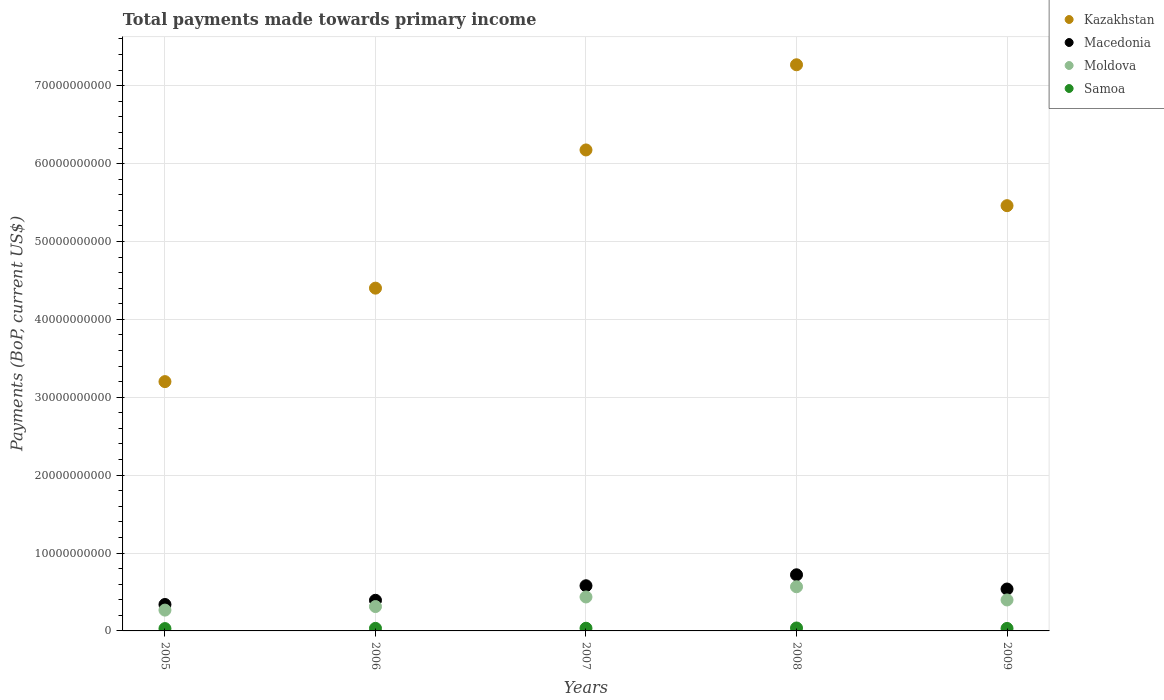Is the number of dotlines equal to the number of legend labels?
Ensure brevity in your answer.  Yes. What is the total payments made towards primary income in Macedonia in 2009?
Your answer should be very brief. 5.38e+09. Across all years, what is the maximum total payments made towards primary income in Samoa?
Give a very brief answer. 3.77e+08. Across all years, what is the minimum total payments made towards primary income in Kazakhstan?
Ensure brevity in your answer.  3.20e+1. What is the total total payments made towards primary income in Kazakhstan in the graph?
Provide a short and direct response. 2.65e+11. What is the difference between the total payments made towards primary income in Samoa in 2007 and that in 2008?
Make the answer very short. -3.25e+07. What is the difference between the total payments made towards primary income in Moldova in 2005 and the total payments made towards primary income in Macedonia in 2007?
Offer a terse response. -3.13e+09. What is the average total payments made towards primary income in Macedonia per year?
Offer a terse response. 5.14e+09. In the year 2008, what is the difference between the total payments made towards primary income in Kazakhstan and total payments made towards primary income in Macedonia?
Your answer should be compact. 6.55e+1. What is the ratio of the total payments made towards primary income in Macedonia in 2005 to that in 2008?
Offer a terse response. 0.47. Is the difference between the total payments made towards primary income in Kazakhstan in 2006 and 2007 greater than the difference between the total payments made towards primary income in Macedonia in 2006 and 2007?
Provide a short and direct response. No. What is the difference between the highest and the second highest total payments made towards primary income in Samoa?
Your response must be concise. 3.25e+07. What is the difference between the highest and the lowest total payments made towards primary income in Macedonia?
Keep it short and to the point. 3.81e+09. Is the sum of the total payments made towards primary income in Samoa in 2006 and 2007 greater than the maximum total payments made towards primary income in Moldova across all years?
Make the answer very short. No. Does the total payments made towards primary income in Kazakhstan monotonically increase over the years?
Ensure brevity in your answer.  No. What is the difference between two consecutive major ticks on the Y-axis?
Offer a terse response. 1.00e+1. Where does the legend appear in the graph?
Offer a very short reply. Top right. How many legend labels are there?
Make the answer very short. 4. How are the legend labels stacked?
Offer a terse response. Vertical. What is the title of the graph?
Your answer should be compact. Total payments made towards primary income. What is the label or title of the X-axis?
Provide a short and direct response. Years. What is the label or title of the Y-axis?
Your response must be concise. Payments (BoP, current US$). What is the Payments (BoP, current US$) in Kazakhstan in 2005?
Your answer should be very brief. 3.20e+1. What is the Payments (BoP, current US$) of Macedonia in 2005?
Ensure brevity in your answer.  3.39e+09. What is the Payments (BoP, current US$) of Moldova in 2005?
Keep it short and to the point. 2.67e+09. What is the Payments (BoP, current US$) in Samoa in 2005?
Provide a succinct answer. 3.00e+08. What is the Payments (BoP, current US$) in Kazakhstan in 2006?
Your answer should be compact. 4.40e+1. What is the Payments (BoP, current US$) in Macedonia in 2006?
Your answer should be compact. 3.93e+09. What is the Payments (BoP, current US$) in Moldova in 2006?
Ensure brevity in your answer.  3.13e+09. What is the Payments (BoP, current US$) in Samoa in 2006?
Your answer should be very brief. 3.29e+08. What is the Payments (BoP, current US$) in Kazakhstan in 2007?
Your answer should be very brief. 6.18e+1. What is the Payments (BoP, current US$) in Macedonia in 2007?
Ensure brevity in your answer.  5.80e+09. What is the Payments (BoP, current US$) in Moldova in 2007?
Provide a succinct answer. 4.36e+09. What is the Payments (BoP, current US$) in Samoa in 2007?
Keep it short and to the point. 3.44e+08. What is the Payments (BoP, current US$) of Kazakhstan in 2008?
Provide a succinct answer. 7.27e+1. What is the Payments (BoP, current US$) in Macedonia in 2008?
Keep it short and to the point. 7.21e+09. What is the Payments (BoP, current US$) in Moldova in 2008?
Offer a very short reply. 5.67e+09. What is the Payments (BoP, current US$) in Samoa in 2008?
Keep it short and to the point. 3.77e+08. What is the Payments (BoP, current US$) of Kazakhstan in 2009?
Make the answer very short. 5.46e+1. What is the Payments (BoP, current US$) in Macedonia in 2009?
Your answer should be very brief. 5.38e+09. What is the Payments (BoP, current US$) of Moldova in 2009?
Your answer should be very brief. 3.97e+09. What is the Payments (BoP, current US$) of Samoa in 2009?
Your response must be concise. 3.20e+08. Across all years, what is the maximum Payments (BoP, current US$) of Kazakhstan?
Keep it short and to the point. 7.27e+1. Across all years, what is the maximum Payments (BoP, current US$) in Macedonia?
Keep it short and to the point. 7.21e+09. Across all years, what is the maximum Payments (BoP, current US$) in Moldova?
Offer a very short reply. 5.67e+09. Across all years, what is the maximum Payments (BoP, current US$) in Samoa?
Make the answer very short. 3.77e+08. Across all years, what is the minimum Payments (BoP, current US$) of Kazakhstan?
Your answer should be very brief. 3.20e+1. Across all years, what is the minimum Payments (BoP, current US$) of Macedonia?
Keep it short and to the point. 3.39e+09. Across all years, what is the minimum Payments (BoP, current US$) of Moldova?
Make the answer very short. 2.67e+09. Across all years, what is the minimum Payments (BoP, current US$) in Samoa?
Your response must be concise. 3.00e+08. What is the total Payments (BoP, current US$) of Kazakhstan in the graph?
Provide a succinct answer. 2.65e+11. What is the total Payments (BoP, current US$) in Macedonia in the graph?
Give a very brief answer. 2.57e+1. What is the total Payments (BoP, current US$) of Moldova in the graph?
Provide a succinct answer. 1.98e+1. What is the total Payments (BoP, current US$) in Samoa in the graph?
Your response must be concise. 1.67e+09. What is the difference between the Payments (BoP, current US$) in Kazakhstan in 2005 and that in 2006?
Keep it short and to the point. -1.20e+1. What is the difference between the Payments (BoP, current US$) in Macedonia in 2005 and that in 2006?
Provide a short and direct response. -5.40e+08. What is the difference between the Payments (BoP, current US$) in Moldova in 2005 and that in 2006?
Ensure brevity in your answer.  -4.56e+08. What is the difference between the Payments (BoP, current US$) of Samoa in 2005 and that in 2006?
Your response must be concise. -2.86e+07. What is the difference between the Payments (BoP, current US$) of Kazakhstan in 2005 and that in 2007?
Your answer should be very brief. -2.97e+1. What is the difference between the Payments (BoP, current US$) of Macedonia in 2005 and that in 2007?
Provide a short and direct response. -2.41e+09. What is the difference between the Payments (BoP, current US$) of Moldova in 2005 and that in 2007?
Keep it short and to the point. -1.69e+09. What is the difference between the Payments (BoP, current US$) of Samoa in 2005 and that in 2007?
Your answer should be very brief. -4.42e+07. What is the difference between the Payments (BoP, current US$) in Kazakhstan in 2005 and that in 2008?
Make the answer very short. -4.07e+1. What is the difference between the Payments (BoP, current US$) in Macedonia in 2005 and that in 2008?
Offer a terse response. -3.81e+09. What is the difference between the Payments (BoP, current US$) in Moldova in 2005 and that in 2008?
Your answer should be compact. -3.00e+09. What is the difference between the Payments (BoP, current US$) in Samoa in 2005 and that in 2008?
Offer a very short reply. -7.67e+07. What is the difference between the Payments (BoP, current US$) of Kazakhstan in 2005 and that in 2009?
Your answer should be compact. -2.26e+1. What is the difference between the Payments (BoP, current US$) in Macedonia in 2005 and that in 2009?
Keep it short and to the point. -1.99e+09. What is the difference between the Payments (BoP, current US$) of Moldova in 2005 and that in 2009?
Provide a succinct answer. -1.30e+09. What is the difference between the Payments (BoP, current US$) of Samoa in 2005 and that in 2009?
Offer a terse response. -1.96e+07. What is the difference between the Payments (BoP, current US$) of Kazakhstan in 2006 and that in 2007?
Make the answer very short. -1.77e+1. What is the difference between the Payments (BoP, current US$) in Macedonia in 2006 and that in 2007?
Your answer should be very brief. -1.87e+09. What is the difference between the Payments (BoP, current US$) in Moldova in 2006 and that in 2007?
Make the answer very short. -1.23e+09. What is the difference between the Payments (BoP, current US$) of Samoa in 2006 and that in 2007?
Your answer should be very brief. -1.56e+07. What is the difference between the Payments (BoP, current US$) in Kazakhstan in 2006 and that in 2008?
Provide a succinct answer. -2.87e+1. What is the difference between the Payments (BoP, current US$) in Macedonia in 2006 and that in 2008?
Your answer should be very brief. -3.27e+09. What is the difference between the Payments (BoP, current US$) of Moldova in 2006 and that in 2008?
Offer a terse response. -2.54e+09. What is the difference between the Payments (BoP, current US$) of Samoa in 2006 and that in 2008?
Offer a very short reply. -4.81e+07. What is the difference between the Payments (BoP, current US$) of Kazakhstan in 2006 and that in 2009?
Make the answer very short. -1.06e+1. What is the difference between the Payments (BoP, current US$) of Macedonia in 2006 and that in 2009?
Offer a terse response. -1.45e+09. What is the difference between the Payments (BoP, current US$) in Moldova in 2006 and that in 2009?
Offer a terse response. -8.46e+08. What is the difference between the Payments (BoP, current US$) in Samoa in 2006 and that in 2009?
Ensure brevity in your answer.  8.97e+06. What is the difference between the Payments (BoP, current US$) of Kazakhstan in 2007 and that in 2008?
Provide a succinct answer. -1.09e+1. What is the difference between the Payments (BoP, current US$) in Macedonia in 2007 and that in 2008?
Ensure brevity in your answer.  -1.41e+09. What is the difference between the Payments (BoP, current US$) in Moldova in 2007 and that in 2008?
Your response must be concise. -1.31e+09. What is the difference between the Payments (BoP, current US$) in Samoa in 2007 and that in 2008?
Your answer should be compact. -3.25e+07. What is the difference between the Payments (BoP, current US$) of Kazakhstan in 2007 and that in 2009?
Ensure brevity in your answer.  7.15e+09. What is the difference between the Payments (BoP, current US$) in Macedonia in 2007 and that in 2009?
Keep it short and to the point. 4.20e+08. What is the difference between the Payments (BoP, current US$) in Moldova in 2007 and that in 2009?
Keep it short and to the point. 3.84e+08. What is the difference between the Payments (BoP, current US$) in Samoa in 2007 and that in 2009?
Provide a short and direct response. 2.46e+07. What is the difference between the Payments (BoP, current US$) of Kazakhstan in 2008 and that in 2009?
Provide a short and direct response. 1.81e+1. What is the difference between the Payments (BoP, current US$) in Macedonia in 2008 and that in 2009?
Make the answer very short. 1.83e+09. What is the difference between the Payments (BoP, current US$) in Moldova in 2008 and that in 2009?
Offer a terse response. 1.70e+09. What is the difference between the Payments (BoP, current US$) in Samoa in 2008 and that in 2009?
Your answer should be compact. 5.70e+07. What is the difference between the Payments (BoP, current US$) in Kazakhstan in 2005 and the Payments (BoP, current US$) in Macedonia in 2006?
Offer a terse response. 2.81e+1. What is the difference between the Payments (BoP, current US$) in Kazakhstan in 2005 and the Payments (BoP, current US$) in Moldova in 2006?
Provide a short and direct response. 2.89e+1. What is the difference between the Payments (BoP, current US$) in Kazakhstan in 2005 and the Payments (BoP, current US$) in Samoa in 2006?
Provide a succinct answer. 3.17e+1. What is the difference between the Payments (BoP, current US$) of Macedonia in 2005 and the Payments (BoP, current US$) of Moldova in 2006?
Keep it short and to the point. 2.64e+08. What is the difference between the Payments (BoP, current US$) in Macedonia in 2005 and the Payments (BoP, current US$) in Samoa in 2006?
Ensure brevity in your answer.  3.06e+09. What is the difference between the Payments (BoP, current US$) in Moldova in 2005 and the Payments (BoP, current US$) in Samoa in 2006?
Your answer should be compact. 2.34e+09. What is the difference between the Payments (BoP, current US$) in Kazakhstan in 2005 and the Payments (BoP, current US$) in Macedonia in 2007?
Offer a terse response. 2.62e+1. What is the difference between the Payments (BoP, current US$) of Kazakhstan in 2005 and the Payments (BoP, current US$) of Moldova in 2007?
Give a very brief answer. 2.76e+1. What is the difference between the Payments (BoP, current US$) of Kazakhstan in 2005 and the Payments (BoP, current US$) of Samoa in 2007?
Provide a succinct answer. 3.17e+1. What is the difference between the Payments (BoP, current US$) in Macedonia in 2005 and the Payments (BoP, current US$) in Moldova in 2007?
Keep it short and to the point. -9.66e+08. What is the difference between the Payments (BoP, current US$) of Macedonia in 2005 and the Payments (BoP, current US$) of Samoa in 2007?
Provide a succinct answer. 3.05e+09. What is the difference between the Payments (BoP, current US$) of Moldova in 2005 and the Payments (BoP, current US$) of Samoa in 2007?
Offer a very short reply. 2.33e+09. What is the difference between the Payments (BoP, current US$) of Kazakhstan in 2005 and the Payments (BoP, current US$) of Macedonia in 2008?
Provide a succinct answer. 2.48e+1. What is the difference between the Payments (BoP, current US$) of Kazakhstan in 2005 and the Payments (BoP, current US$) of Moldova in 2008?
Make the answer very short. 2.63e+1. What is the difference between the Payments (BoP, current US$) of Kazakhstan in 2005 and the Payments (BoP, current US$) of Samoa in 2008?
Give a very brief answer. 3.16e+1. What is the difference between the Payments (BoP, current US$) in Macedonia in 2005 and the Payments (BoP, current US$) in Moldova in 2008?
Your response must be concise. -2.28e+09. What is the difference between the Payments (BoP, current US$) in Macedonia in 2005 and the Payments (BoP, current US$) in Samoa in 2008?
Provide a short and direct response. 3.02e+09. What is the difference between the Payments (BoP, current US$) in Moldova in 2005 and the Payments (BoP, current US$) in Samoa in 2008?
Provide a succinct answer. 2.30e+09. What is the difference between the Payments (BoP, current US$) of Kazakhstan in 2005 and the Payments (BoP, current US$) of Macedonia in 2009?
Offer a terse response. 2.66e+1. What is the difference between the Payments (BoP, current US$) in Kazakhstan in 2005 and the Payments (BoP, current US$) in Moldova in 2009?
Provide a short and direct response. 2.80e+1. What is the difference between the Payments (BoP, current US$) of Kazakhstan in 2005 and the Payments (BoP, current US$) of Samoa in 2009?
Provide a succinct answer. 3.17e+1. What is the difference between the Payments (BoP, current US$) of Macedonia in 2005 and the Payments (BoP, current US$) of Moldova in 2009?
Offer a very short reply. -5.82e+08. What is the difference between the Payments (BoP, current US$) in Macedonia in 2005 and the Payments (BoP, current US$) in Samoa in 2009?
Ensure brevity in your answer.  3.07e+09. What is the difference between the Payments (BoP, current US$) in Moldova in 2005 and the Payments (BoP, current US$) in Samoa in 2009?
Make the answer very short. 2.35e+09. What is the difference between the Payments (BoP, current US$) in Kazakhstan in 2006 and the Payments (BoP, current US$) in Macedonia in 2007?
Your answer should be very brief. 3.82e+1. What is the difference between the Payments (BoP, current US$) of Kazakhstan in 2006 and the Payments (BoP, current US$) of Moldova in 2007?
Offer a terse response. 3.96e+1. What is the difference between the Payments (BoP, current US$) of Kazakhstan in 2006 and the Payments (BoP, current US$) of Samoa in 2007?
Your response must be concise. 4.37e+1. What is the difference between the Payments (BoP, current US$) of Macedonia in 2006 and the Payments (BoP, current US$) of Moldova in 2007?
Provide a short and direct response. -4.26e+08. What is the difference between the Payments (BoP, current US$) in Macedonia in 2006 and the Payments (BoP, current US$) in Samoa in 2007?
Your answer should be compact. 3.59e+09. What is the difference between the Payments (BoP, current US$) of Moldova in 2006 and the Payments (BoP, current US$) of Samoa in 2007?
Provide a succinct answer. 2.78e+09. What is the difference between the Payments (BoP, current US$) of Kazakhstan in 2006 and the Payments (BoP, current US$) of Macedonia in 2008?
Your response must be concise. 3.68e+1. What is the difference between the Payments (BoP, current US$) in Kazakhstan in 2006 and the Payments (BoP, current US$) in Moldova in 2008?
Make the answer very short. 3.83e+1. What is the difference between the Payments (BoP, current US$) in Kazakhstan in 2006 and the Payments (BoP, current US$) in Samoa in 2008?
Ensure brevity in your answer.  4.36e+1. What is the difference between the Payments (BoP, current US$) of Macedonia in 2006 and the Payments (BoP, current US$) of Moldova in 2008?
Your answer should be compact. -1.74e+09. What is the difference between the Payments (BoP, current US$) in Macedonia in 2006 and the Payments (BoP, current US$) in Samoa in 2008?
Your answer should be very brief. 3.56e+09. What is the difference between the Payments (BoP, current US$) in Moldova in 2006 and the Payments (BoP, current US$) in Samoa in 2008?
Your answer should be compact. 2.75e+09. What is the difference between the Payments (BoP, current US$) of Kazakhstan in 2006 and the Payments (BoP, current US$) of Macedonia in 2009?
Your answer should be very brief. 3.86e+1. What is the difference between the Payments (BoP, current US$) of Kazakhstan in 2006 and the Payments (BoP, current US$) of Moldova in 2009?
Ensure brevity in your answer.  4.00e+1. What is the difference between the Payments (BoP, current US$) of Kazakhstan in 2006 and the Payments (BoP, current US$) of Samoa in 2009?
Make the answer very short. 4.37e+1. What is the difference between the Payments (BoP, current US$) in Macedonia in 2006 and the Payments (BoP, current US$) in Moldova in 2009?
Offer a very short reply. -4.25e+07. What is the difference between the Payments (BoP, current US$) of Macedonia in 2006 and the Payments (BoP, current US$) of Samoa in 2009?
Give a very brief answer. 3.61e+09. What is the difference between the Payments (BoP, current US$) of Moldova in 2006 and the Payments (BoP, current US$) of Samoa in 2009?
Keep it short and to the point. 2.81e+09. What is the difference between the Payments (BoP, current US$) of Kazakhstan in 2007 and the Payments (BoP, current US$) of Macedonia in 2008?
Offer a terse response. 5.45e+1. What is the difference between the Payments (BoP, current US$) in Kazakhstan in 2007 and the Payments (BoP, current US$) in Moldova in 2008?
Offer a very short reply. 5.61e+1. What is the difference between the Payments (BoP, current US$) in Kazakhstan in 2007 and the Payments (BoP, current US$) in Samoa in 2008?
Provide a succinct answer. 6.14e+1. What is the difference between the Payments (BoP, current US$) of Macedonia in 2007 and the Payments (BoP, current US$) of Moldova in 2008?
Provide a short and direct response. 1.28e+08. What is the difference between the Payments (BoP, current US$) in Macedonia in 2007 and the Payments (BoP, current US$) in Samoa in 2008?
Offer a terse response. 5.42e+09. What is the difference between the Payments (BoP, current US$) in Moldova in 2007 and the Payments (BoP, current US$) in Samoa in 2008?
Your response must be concise. 3.98e+09. What is the difference between the Payments (BoP, current US$) of Kazakhstan in 2007 and the Payments (BoP, current US$) of Macedonia in 2009?
Provide a short and direct response. 5.64e+1. What is the difference between the Payments (BoP, current US$) in Kazakhstan in 2007 and the Payments (BoP, current US$) in Moldova in 2009?
Give a very brief answer. 5.78e+1. What is the difference between the Payments (BoP, current US$) in Kazakhstan in 2007 and the Payments (BoP, current US$) in Samoa in 2009?
Ensure brevity in your answer.  6.14e+1. What is the difference between the Payments (BoP, current US$) of Macedonia in 2007 and the Payments (BoP, current US$) of Moldova in 2009?
Keep it short and to the point. 1.82e+09. What is the difference between the Payments (BoP, current US$) in Macedonia in 2007 and the Payments (BoP, current US$) in Samoa in 2009?
Offer a very short reply. 5.48e+09. What is the difference between the Payments (BoP, current US$) in Moldova in 2007 and the Payments (BoP, current US$) in Samoa in 2009?
Offer a terse response. 4.04e+09. What is the difference between the Payments (BoP, current US$) of Kazakhstan in 2008 and the Payments (BoP, current US$) of Macedonia in 2009?
Provide a succinct answer. 6.73e+1. What is the difference between the Payments (BoP, current US$) of Kazakhstan in 2008 and the Payments (BoP, current US$) of Moldova in 2009?
Offer a terse response. 6.87e+1. What is the difference between the Payments (BoP, current US$) of Kazakhstan in 2008 and the Payments (BoP, current US$) of Samoa in 2009?
Your answer should be compact. 7.24e+1. What is the difference between the Payments (BoP, current US$) in Macedonia in 2008 and the Payments (BoP, current US$) in Moldova in 2009?
Your answer should be very brief. 3.23e+09. What is the difference between the Payments (BoP, current US$) in Macedonia in 2008 and the Payments (BoP, current US$) in Samoa in 2009?
Make the answer very short. 6.89e+09. What is the difference between the Payments (BoP, current US$) in Moldova in 2008 and the Payments (BoP, current US$) in Samoa in 2009?
Provide a succinct answer. 5.35e+09. What is the average Payments (BoP, current US$) of Kazakhstan per year?
Give a very brief answer. 5.30e+1. What is the average Payments (BoP, current US$) in Macedonia per year?
Your answer should be compact. 5.14e+09. What is the average Payments (BoP, current US$) in Moldova per year?
Keep it short and to the point. 3.96e+09. What is the average Payments (BoP, current US$) of Samoa per year?
Keep it short and to the point. 3.34e+08. In the year 2005, what is the difference between the Payments (BoP, current US$) in Kazakhstan and Payments (BoP, current US$) in Macedonia?
Provide a short and direct response. 2.86e+1. In the year 2005, what is the difference between the Payments (BoP, current US$) in Kazakhstan and Payments (BoP, current US$) in Moldova?
Ensure brevity in your answer.  2.93e+1. In the year 2005, what is the difference between the Payments (BoP, current US$) in Kazakhstan and Payments (BoP, current US$) in Samoa?
Give a very brief answer. 3.17e+1. In the year 2005, what is the difference between the Payments (BoP, current US$) in Macedonia and Payments (BoP, current US$) in Moldova?
Your answer should be compact. 7.20e+08. In the year 2005, what is the difference between the Payments (BoP, current US$) in Macedonia and Payments (BoP, current US$) in Samoa?
Provide a succinct answer. 3.09e+09. In the year 2005, what is the difference between the Payments (BoP, current US$) of Moldova and Payments (BoP, current US$) of Samoa?
Your answer should be compact. 2.37e+09. In the year 2006, what is the difference between the Payments (BoP, current US$) of Kazakhstan and Payments (BoP, current US$) of Macedonia?
Your response must be concise. 4.01e+1. In the year 2006, what is the difference between the Payments (BoP, current US$) in Kazakhstan and Payments (BoP, current US$) in Moldova?
Offer a terse response. 4.09e+1. In the year 2006, what is the difference between the Payments (BoP, current US$) of Kazakhstan and Payments (BoP, current US$) of Samoa?
Keep it short and to the point. 4.37e+1. In the year 2006, what is the difference between the Payments (BoP, current US$) in Macedonia and Payments (BoP, current US$) in Moldova?
Give a very brief answer. 8.04e+08. In the year 2006, what is the difference between the Payments (BoP, current US$) in Macedonia and Payments (BoP, current US$) in Samoa?
Ensure brevity in your answer.  3.60e+09. In the year 2006, what is the difference between the Payments (BoP, current US$) in Moldova and Payments (BoP, current US$) in Samoa?
Give a very brief answer. 2.80e+09. In the year 2007, what is the difference between the Payments (BoP, current US$) in Kazakhstan and Payments (BoP, current US$) in Macedonia?
Provide a short and direct response. 5.60e+1. In the year 2007, what is the difference between the Payments (BoP, current US$) in Kazakhstan and Payments (BoP, current US$) in Moldova?
Make the answer very short. 5.74e+1. In the year 2007, what is the difference between the Payments (BoP, current US$) in Kazakhstan and Payments (BoP, current US$) in Samoa?
Offer a very short reply. 6.14e+1. In the year 2007, what is the difference between the Payments (BoP, current US$) of Macedonia and Payments (BoP, current US$) of Moldova?
Offer a terse response. 1.44e+09. In the year 2007, what is the difference between the Payments (BoP, current US$) of Macedonia and Payments (BoP, current US$) of Samoa?
Provide a succinct answer. 5.45e+09. In the year 2007, what is the difference between the Payments (BoP, current US$) in Moldova and Payments (BoP, current US$) in Samoa?
Give a very brief answer. 4.01e+09. In the year 2008, what is the difference between the Payments (BoP, current US$) in Kazakhstan and Payments (BoP, current US$) in Macedonia?
Keep it short and to the point. 6.55e+1. In the year 2008, what is the difference between the Payments (BoP, current US$) of Kazakhstan and Payments (BoP, current US$) of Moldova?
Keep it short and to the point. 6.70e+1. In the year 2008, what is the difference between the Payments (BoP, current US$) of Kazakhstan and Payments (BoP, current US$) of Samoa?
Offer a terse response. 7.23e+1. In the year 2008, what is the difference between the Payments (BoP, current US$) of Macedonia and Payments (BoP, current US$) of Moldova?
Your answer should be compact. 1.54e+09. In the year 2008, what is the difference between the Payments (BoP, current US$) of Macedonia and Payments (BoP, current US$) of Samoa?
Make the answer very short. 6.83e+09. In the year 2008, what is the difference between the Payments (BoP, current US$) of Moldova and Payments (BoP, current US$) of Samoa?
Offer a very short reply. 5.29e+09. In the year 2009, what is the difference between the Payments (BoP, current US$) of Kazakhstan and Payments (BoP, current US$) of Macedonia?
Ensure brevity in your answer.  4.92e+1. In the year 2009, what is the difference between the Payments (BoP, current US$) in Kazakhstan and Payments (BoP, current US$) in Moldova?
Offer a very short reply. 5.06e+1. In the year 2009, what is the difference between the Payments (BoP, current US$) in Kazakhstan and Payments (BoP, current US$) in Samoa?
Offer a very short reply. 5.43e+1. In the year 2009, what is the difference between the Payments (BoP, current US$) in Macedonia and Payments (BoP, current US$) in Moldova?
Provide a short and direct response. 1.40e+09. In the year 2009, what is the difference between the Payments (BoP, current US$) in Macedonia and Payments (BoP, current US$) in Samoa?
Make the answer very short. 5.06e+09. In the year 2009, what is the difference between the Payments (BoP, current US$) of Moldova and Payments (BoP, current US$) of Samoa?
Offer a terse response. 3.66e+09. What is the ratio of the Payments (BoP, current US$) of Kazakhstan in 2005 to that in 2006?
Your response must be concise. 0.73. What is the ratio of the Payments (BoP, current US$) of Macedonia in 2005 to that in 2006?
Make the answer very short. 0.86. What is the ratio of the Payments (BoP, current US$) in Moldova in 2005 to that in 2006?
Provide a succinct answer. 0.85. What is the ratio of the Payments (BoP, current US$) in Samoa in 2005 to that in 2006?
Your answer should be compact. 0.91. What is the ratio of the Payments (BoP, current US$) of Kazakhstan in 2005 to that in 2007?
Provide a short and direct response. 0.52. What is the ratio of the Payments (BoP, current US$) in Macedonia in 2005 to that in 2007?
Your answer should be compact. 0.59. What is the ratio of the Payments (BoP, current US$) of Moldova in 2005 to that in 2007?
Make the answer very short. 0.61. What is the ratio of the Payments (BoP, current US$) of Samoa in 2005 to that in 2007?
Provide a succinct answer. 0.87. What is the ratio of the Payments (BoP, current US$) in Kazakhstan in 2005 to that in 2008?
Give a very brief answer. 0.44. What is the ratio of the Payments (BoP, current US$) in Macedonia in 2005 to that in 2008?
Your answer should be very brief. 0.47. What is the ratio of the Payments (BoP, current US$) of Moldova in 2005 to that in 2008?
Provide a succinct answer. 0.47. What is the ratio of the Payments (BoP, current US$) of Samoa in 2005 to that in 2008?
Your answer should be compact. 0.8. What is the ratio of the Payments (BoP, current US$) of Kazakhstan in 2005 to that in 2009?
Provide a short and direct response. 0.59. What is the ratio of the Payments (BoP, current US$) of Macedonia in 2005 to that in 2009?
Provide a succinct answer. 0.63. What is the ratio of the Payments (BoP, current US$) of Moldova in 2005 to that in 2009?
Offer a very short reply. 0.67. What is the ratio of the Payments (BoP, current US$) of Samoa in 2005 to that in 2009?
Offer a terse response. 0.94. What is the ratio of the Payments (BoP, current US$) of Kazakhstan in 2006 to that in 2007?
Provide a succinct answer. 0.71. What is the ratio of the Payments (BoP, current US$) in Macedonia in 2006 to that in 2007?
Keep it short and to the point. 0.68. What is the ratio of the Payments (BoP, current US$) in Moldova in 2006 to that in 2007?
Provide a succinct answer. 0.72. What is the ratio of the Payments (BoP, current US$) of Samoa in 2006 to that in 2007?
Give a very brief answer. 0.95. What is the ratio of the Payments (BoP, current US$) of Kazakhstan in 2006 to that in 2008?
Offer a terse response. 0.61. What is the ratio of the Payments (BoP, current US$) of Macedonia in 2006 to that in 2008?
Keep it short and to the point. 0.55. What is the ratio of the Payments (BoP, current US$) in Moldova in 2006 to that in 2008?
Provide a short and direct response. 0.55. What is the ratio of the Payments (BoP, current US$) of Samoa in 2006 to that in 2008?
Keep it short and to the point. 0.87. What is the ratio of the Payments (BoP, current US$) in Kazakhstan in 2006 to that in 2009?
Make the answer very short. 0.81. What is the ratio of the Payments (BoP, current US$) of Macedonia in 2006 to that in 2009?
Offer a very short reply. 0.73. What is the ratio of the Payments (BoP, current US$) in Moldova in 2006 to that in 2009?
Ensure brevity in your answer.  0.79. What is the ratio of the Payments (BoP, current US$) in Samoa in 2006 to that in 2009?
Ensure brevity in your answer.  1.03. What is the ratio of the Payments (BoP, current US$) of Kazakhstan in 2007 to that in 2008?
Keep it short and to the point. 0.85. What is the ratio of the Payments (BoP, current US$) of Macedonia in 2007 to that in 2008?
Provide a short and direct response. 0.8. What is the ratio of the Payments (BoP, current US$) in Moldova in 2007 to that in 2008?
Offer a terse response. 0.77. What is the ratio of the Payments (BoP, current US$) of Samoa in 2007 to that in 2008?
Ensure brevity in your answer.  0.91. What is the ratio of the Payments (BoP, current US$) of Kazakhstan in 2007 to that in 2009?
Ensure brevity in your answer.  1.13. What is the ratio of the Payments (BoP, current US$) in Macedonia in 2007 to that in 2009?
Make the answer very short. 1.08. What is the ratio of the Payments (BoP, current US$) of Moldova in 2007 to that in 2009?
Keep it short and to the point. 1.1. What is the ratio of the Payments (BoP, current US$) of Samoa in 2007 to that in 2009?
Offer a terse response. 1.08. What is the ratio of the Payments (BoP, current US$) in Kazakhstan in 2008 to that in 2009?
Make the answer very short. 1.33. What is the ratio of the Payments (BoP, current US$) in Macedonia in 2008 to that in 2009?
Offer a very short reply. 1.34. What is the ratio of the Payments (BoP, current US$) of Moldova in 2008 to that in 2009?
Ensure brevity in your answer.  1.43. What is the ratio of the Payments (BoP, current US$) in Samoa in 2008 to that in 2009?
Give a very brief answer. 1.18. What is the difference between the highest and the second highest Payments (BoP, current US$) of Kazakhstan?
Provide a succinct answer. 1.09e+1. What is the difference between the highest and the second highest Payments (BoP, current US$) in Macedonia?
Offer a terse response. 1.41e+09. What is the difference between the highest and the second highest Payments (BoP, current US$) in Moldova?
Ensure brevity in your answer.  1.31e+09. What is the difference between the highest and the second highest Payments (BoP, current US$) of Samoa?
Offer a terse response. 3.25e+07. What is the difference between the highest and the lowest Payments (BoP, current US$) of Kazakhstan?
Your answer should be very brief. 4.07e+1. What is the difference between the highest and the lowest Payments (BoP, current US$) in Macedonia?
Give a very brief answer. 3.81e+09. What is the difference between the highest and the lowest Payments (BoP, current US$) of Moldova?
Give a very brief answer. 3.00e+09. What is the difference between the highest and the lowest Payments (BoP, current US$) in Samoa?
Keep it short and to the point. 7.67e+07. 